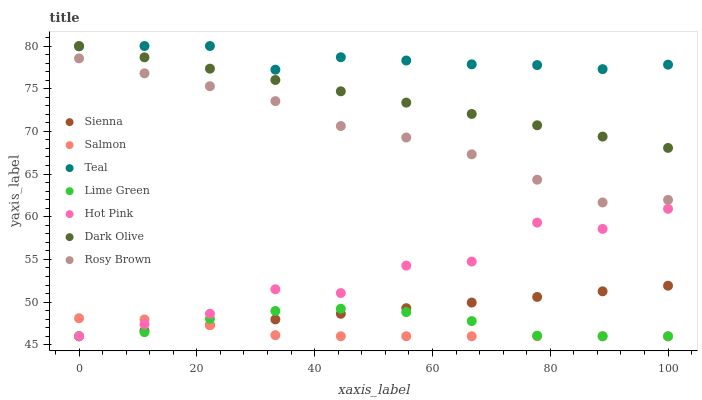Does Salmon have the minimum area under the curve?
Answer yes or no. Yes. Does Teal have the maximum area under the curve?
Answer yes or no. Yes. Does Dark Olive have the minimum area under the curve?
Answer yes or no. No. Does Dark Olive have the maximum area under the curve?
Answer yes or no. No. Is Sienna the smoothest?
Answer yes or no. Yes. Is Hot Pink the roughest?
Answer yes or no. Yes. Is Dark Olive the smoothest?
Answer yes or no. No. Is Dark Olive the roughest?
Answer yes or no. No. Does Hot Pink have the lowest value?
Answer yes or no. Yes. Does Dark Olive have the lowest value?
Answer yes or no. No. Does Teal have the highest value?
Answer yes or no. Yes. Does Salmon have the highest value?
Answer yes or no. No. Is Rosy Brown less than Dark Olive?
Answer yes or no. Yes. Is Dark Olive greater than Lime Green?
Answer yes or no. Yes. Does Salmon intersect Hot Pink?
Answer yes or no. Yes. Is Salmon less than Hot Pink?
Answer yes or no. No. Is Salmon greater than Hot Pink?
Answer yes or no. No. Does Rosy Brown intersect Dark Olive?
Answer yes or no. No. 